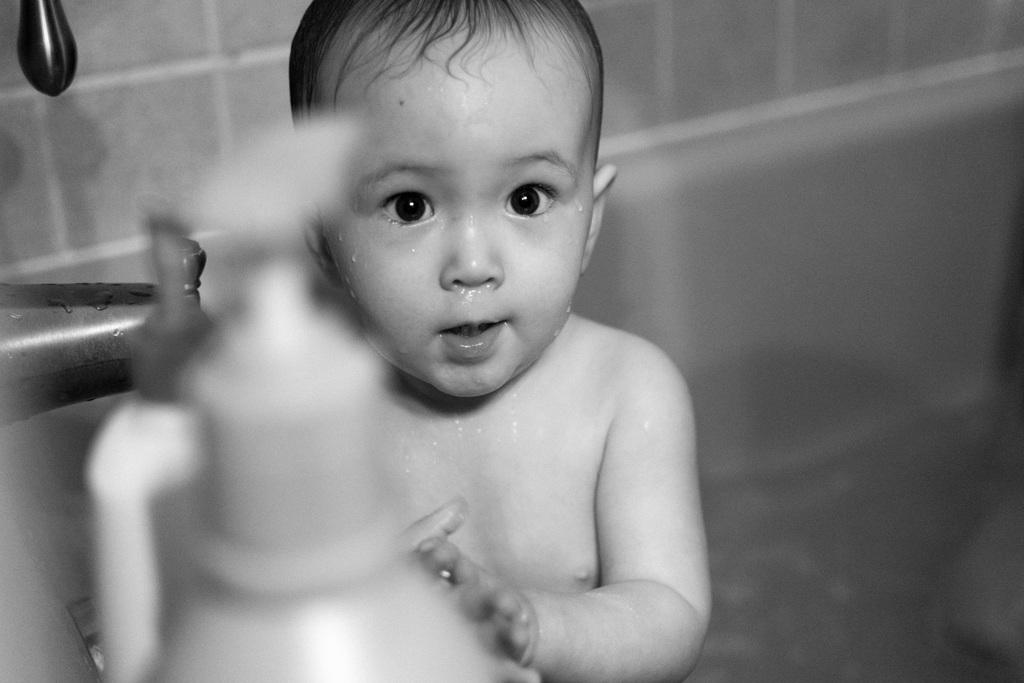What is the color scheme of the image? The image is black and white. Who or what is the main subject in the image? There is a kid in the image. What else can be seen in the image besides the kid? There are bottles and other objects in the image. What is visible in the background of the image? There is a wall in the background of the image. What type of scent can be detected from the objects in the image? There is no information about scents in the image, as it is a visual medium. 